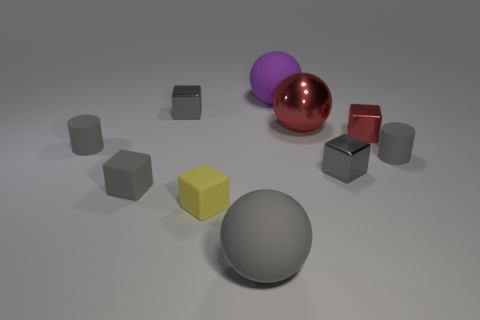Subtract all green cylinders. How many gray cubes are left? 3 Subtract 1 blocks. How many blocks are left? 4 Subtract all cyan cubes. Subtract all yellow cylinders. How many cubes are left? 5 Subtract all cylinders. How many objects are left? 8 Add 6 purple rubber spheres. How many purple rubber spheres are left? 7 Add 2 purple rubber spheres. How many purple rubber spheres exist? 3 Subtract 3 gray cubes. How many objects are left? 7 Subtract all gray metallic blocks. Subtract all gray matte cubes. How many objects are left? 7 